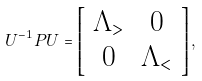Convert formula to latex. <formula><loc_0><loc_0><loc_500><loc_500>U ^ { - 1 } P U = \left [ \begin{array} { c c } \Lambda _ { > } & 0 \\ 0 & \Lambda _ { < } \end{array} \right ] ,</formula> 